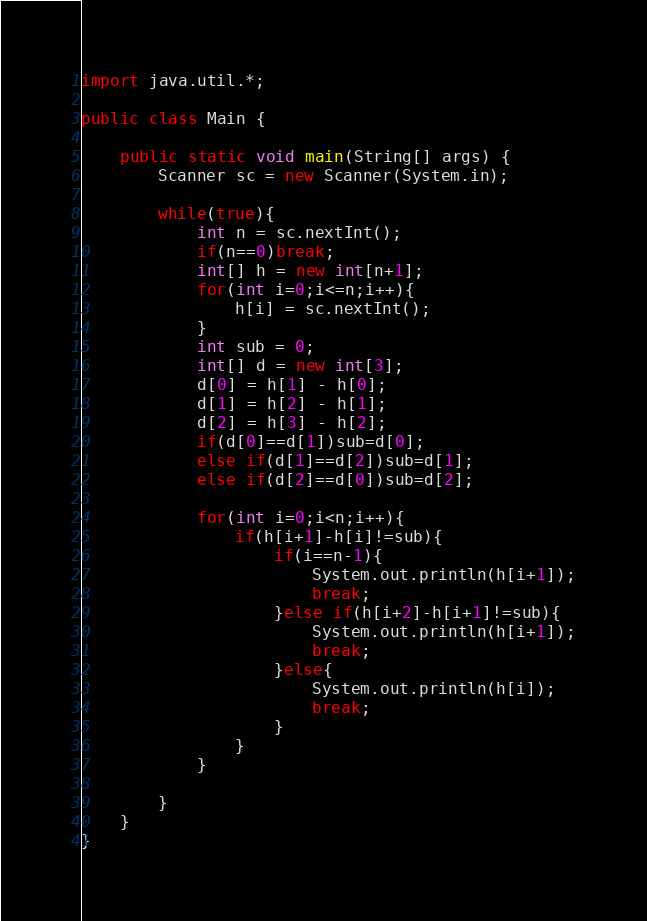<code> <loc_0><loc_0><loc_500><loc_500><_Java_>import java.util.*;

public class Main {

	public static void main(String[] args) {
		Scanner sc = new Scanner(System.in);

		while(true){
			int n = sc.nextInt();
			if(n==0)break;
			int[] h = new int[n+1];
			for(int i=0;i<=n;i++){
				h[i] = sc.nextInt();
			}
			int sub = 0;
			int[] d = new int[3];
			d[0] = h[1] - h[0];
			d[1] = h[2] - h[1];
			d[2] = h[3] - h[2];
			if(d[0]==d[1])sub=d[0];
			else if(d[1]==d[2])sub=d[1];
			else if(d[2]==d[0])sub=d[2];
			
			for(int i=0;i<n;i++){
				if(h[i+1]-h[i]!=sub){
					if(i==n-1){
						System.out.println(h[i+1]);
						break;
					}else if(h[i+2]-h[i+1]!=sub){
						System.out.println(h[i+1]);
						break;
					}else{
						System.out.println(h[i]);
						break;
					}
				}
			}
			
		}
	}
}</code> 